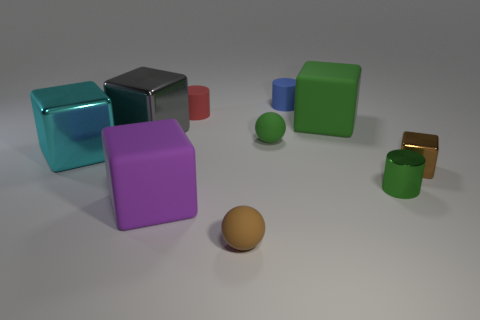What number of brown things are balls or big balls?
Make the answer very short. 1. Are the tiny cylinder in front of the big cyan object and the large purple block made of the same material?
Give a very brief answer. No. How many other objects are there of the same material as the purple object?
Offer a terse response. 5. What is the red thing made of?
Your answer should be very brief. Rubber. There is a brown object that is behind the tiny brown ball; how big is it?
Your answer should be compact. Small. There is a cylinder in front of the large gray thing; how many red cylinders are on the left side of it?
Offer a terse response. 1. Do the large thing right of the large purple thing and the green thing that is in front of the cyan object have the same shape?
Your response must be concise. No. How many large blocks are on the right side of the large cyan metallic block and behind the purple matte thing?
Provide a short and direct response. 2. Is there a rubber ball that has the same color as the metallic cylinder?
Your answer should be compact. Yes. What is the shape of the brown shiny thing that is the same size as the blue thing?
Give a very brief answer. Cube. 